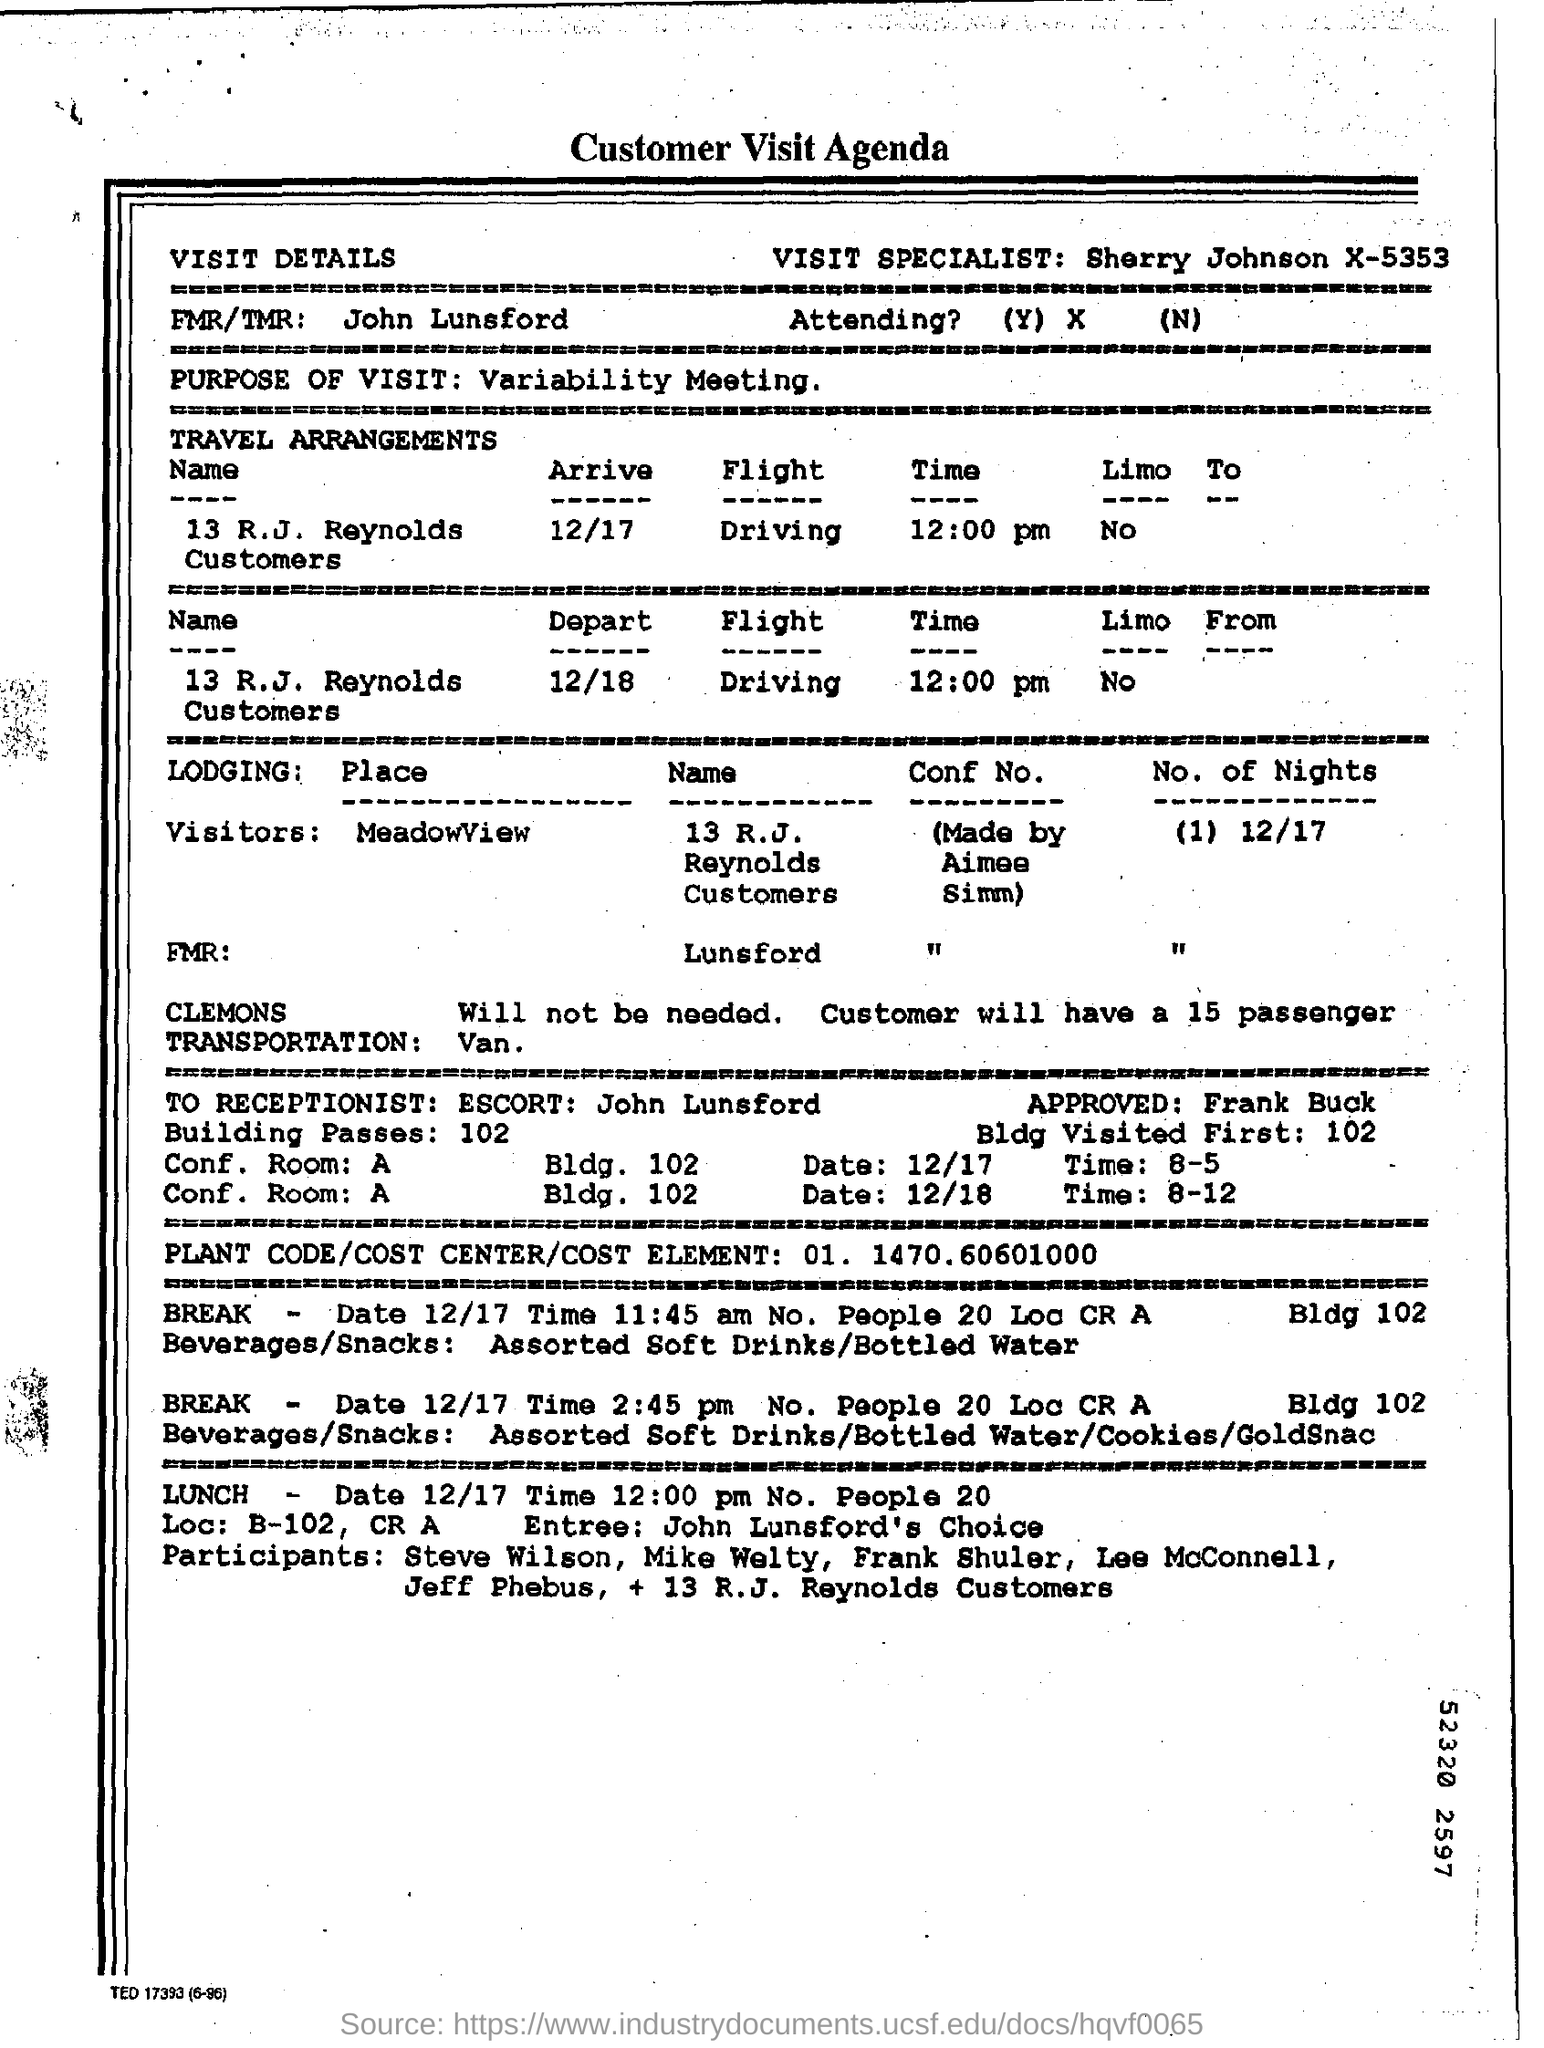Who is the Visit Specialist?
Provide a short and direct response. Sherry Johnson X-5353. Who is the FMR/TMR?
Your answer should be very brief. John Lunsford. What is the Purpose of Visit?
Give a very brief answer. Variability Meeting. What is Lodging "Place" for "Visitors"?
Your answer should be compact. MeadowView. What are the No. of Nights?
Make the answer very short. (1). What is the PLANT CODE/COST CENTER/COST ELEMENT?
Your answer should be compact. 01. 1470. 60601000. 